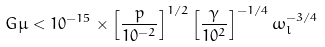Convert formula to latex. <formula><loc_0><loc_0><loc_500><loc_500>G \mu < 1 0 ^ { - 1 5 } \times \left [ \frac { p } { 1 0 ^ { - 2 } } \right ] ^ { 1 / 2 } \left [ \frac { \gamma } { 1 0 ^ { 2 } } \right ] ^ { - 1 / 4 } \omega _ { l } ^ { - 3 / 4 }</formula> 